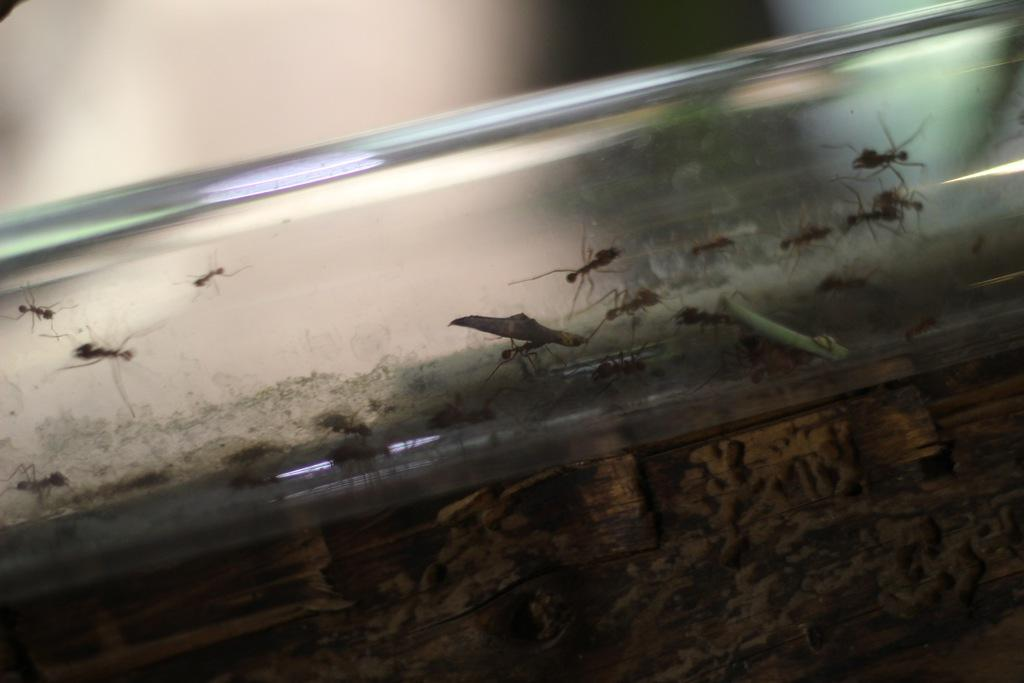What type of creatures are present in the image? There are ants and insects in the image. Where are the ants and insects located? The ants and insects are in a glass tube. What letter is the expert holding in the image? There is no expert or letter present in the image; it features ants and insects in a glass tube. 